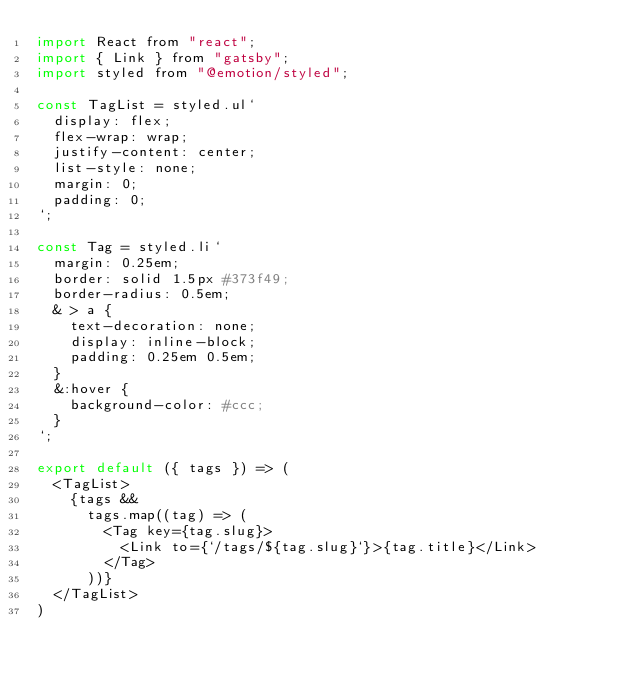Convert code to text. <code><loc_0><loc_0><loc_500><loc_500><_JavaScript_>import React from "react";
import { Link } from "gatsby";
import styled from "@emotion/styled";

const TagList = styled.ul`
  display: flex;
  flex-wrap: wrap;
  justify-content: center;
  list-style: none;
  margin: 0;
  padding: 0;
`;

const Tag = styled.li`
  margin: 0.25em;
  border: solid 1.5px #373f49;
  border-radius: 0.5em;
  & > a {
    text-decoration: none;
    display: inline-block;
    padding: 0.25em 0.5em;
  }
  &:hover {
    background-color: #ccc;
  }
`;

export default ({ tags }) => (
  <TagList>
    {tags &&
      tags.map((tag) => (
        <Tag key={tag.slug}>
          <Link to={`/tags/${tag.slug}`}>{tag.title}</Link>
        </Tag>
      ))}
  </TagList>
)
</code> 